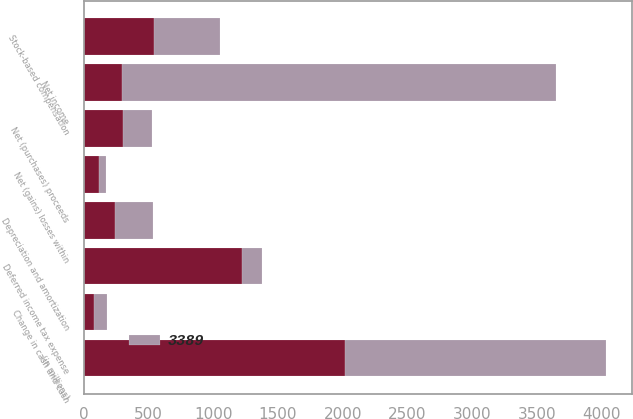<chart> <loc_0><loc_0><loc_500><loc_500><stacked_bar_chart><ecel><fcel>(in millions)<fcel>Net income<fcel>Depreciation and amortization<fcel>Stock-based compensation<fcel>Deferred income tax expense<fcel>Change in cash and cash<fcel>Net (gains) losses within<fcel>Net (purchases) proceeds<nl><fcel>nan<fcel>2017<fcel>295<fcel>240<fcel>542<fcel>1221<fcel>81<fcel>118<fcel>302<nl><fcel>3389<fcel>2015<fcel>3352<fcel>295<fcel>514<fcel>156<fcel>98<fcel>58<fcel>227<nl></chart> 